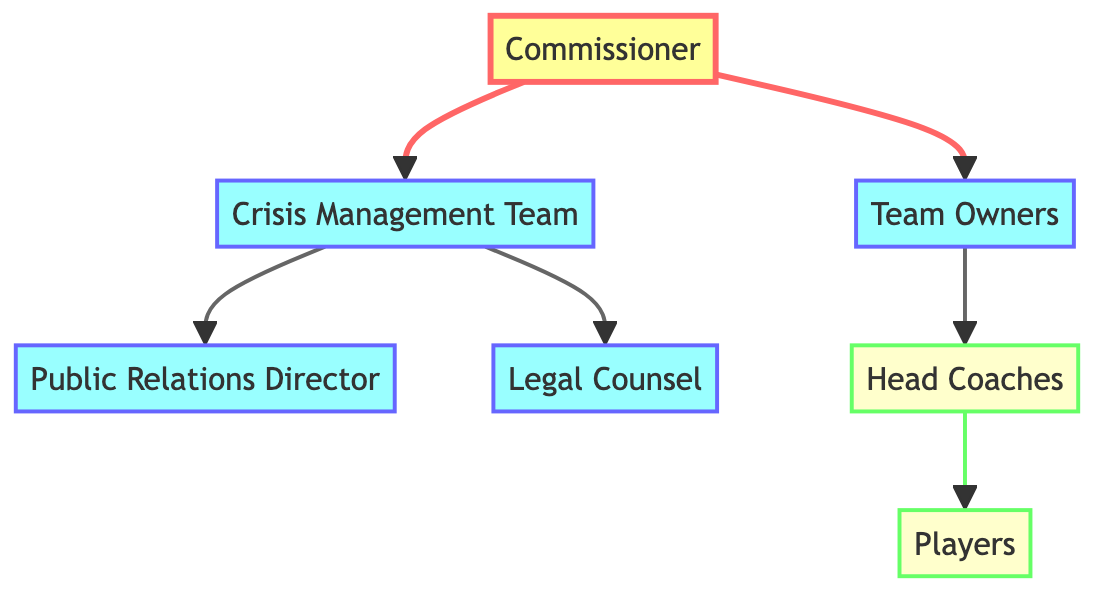What is the top node in the chain of command? The top node is indicated by the first node in the diagram, which is labeled "Commissioner." This node originates the chain of command for crisis management.
Answer: Commissioner How many middle nodes are there? In the diagram, the middle nodes include the "Crisis Management Team," "Team Owners," "Public Relations Director," and "Legal Counsel." Counting these gives a total of four middle nodes.
Answer: Four Who reports directly to the Commissioner? The Commissioner has two nodes that report directly to them: the "Crisis Management Team" and "Team Owners." Both of these relationships originate from the Commissioner.
Answer: Crisis Management Team, Team Owners Which node is directly connected to the Crisis Management Team? The Crisis Management Team has two direct connections leading to "Public Relations Director" and "Legal Counsel." Therefore, both nodes are connected to the Crisis Management Team.
Answer: Public Relations Director, Legal Counsel What is the relationship between Head Coaches and Players? The diagram shows that "Head Coaches" is a node that directly influences the node "Players." This indicates that players report to the head coaches as part of the crisis management structure.
Answer: Head Coaches to Players Which node has the most connections? Evaluating the nodes, the "Crisis Management Team" has two outgoing connections, while all other nodes either connect to one or none. This makes it the node with the most outgoing connections.
Answer: Crisis Management Team What is the role of the Public Relations Director? The Public Relations Director is a node that is part of the structure responding to crises, directly managed by the Crisis Management Team. This indicates that the role involves communication strategies when crises arise within the league.
Answer: Communication strategies How many edges are there in total? Counting the directed connections (edges) in the diagram, there are one connection from Commissioner to Crisis Management, one to Team Owners, two from Crisis Management Team (to Public Relations Director and Legal Counsel), one from Team Owners to Head Coaches, and one from Head Coaches to Players, totaling six edges.
Answer: Six 